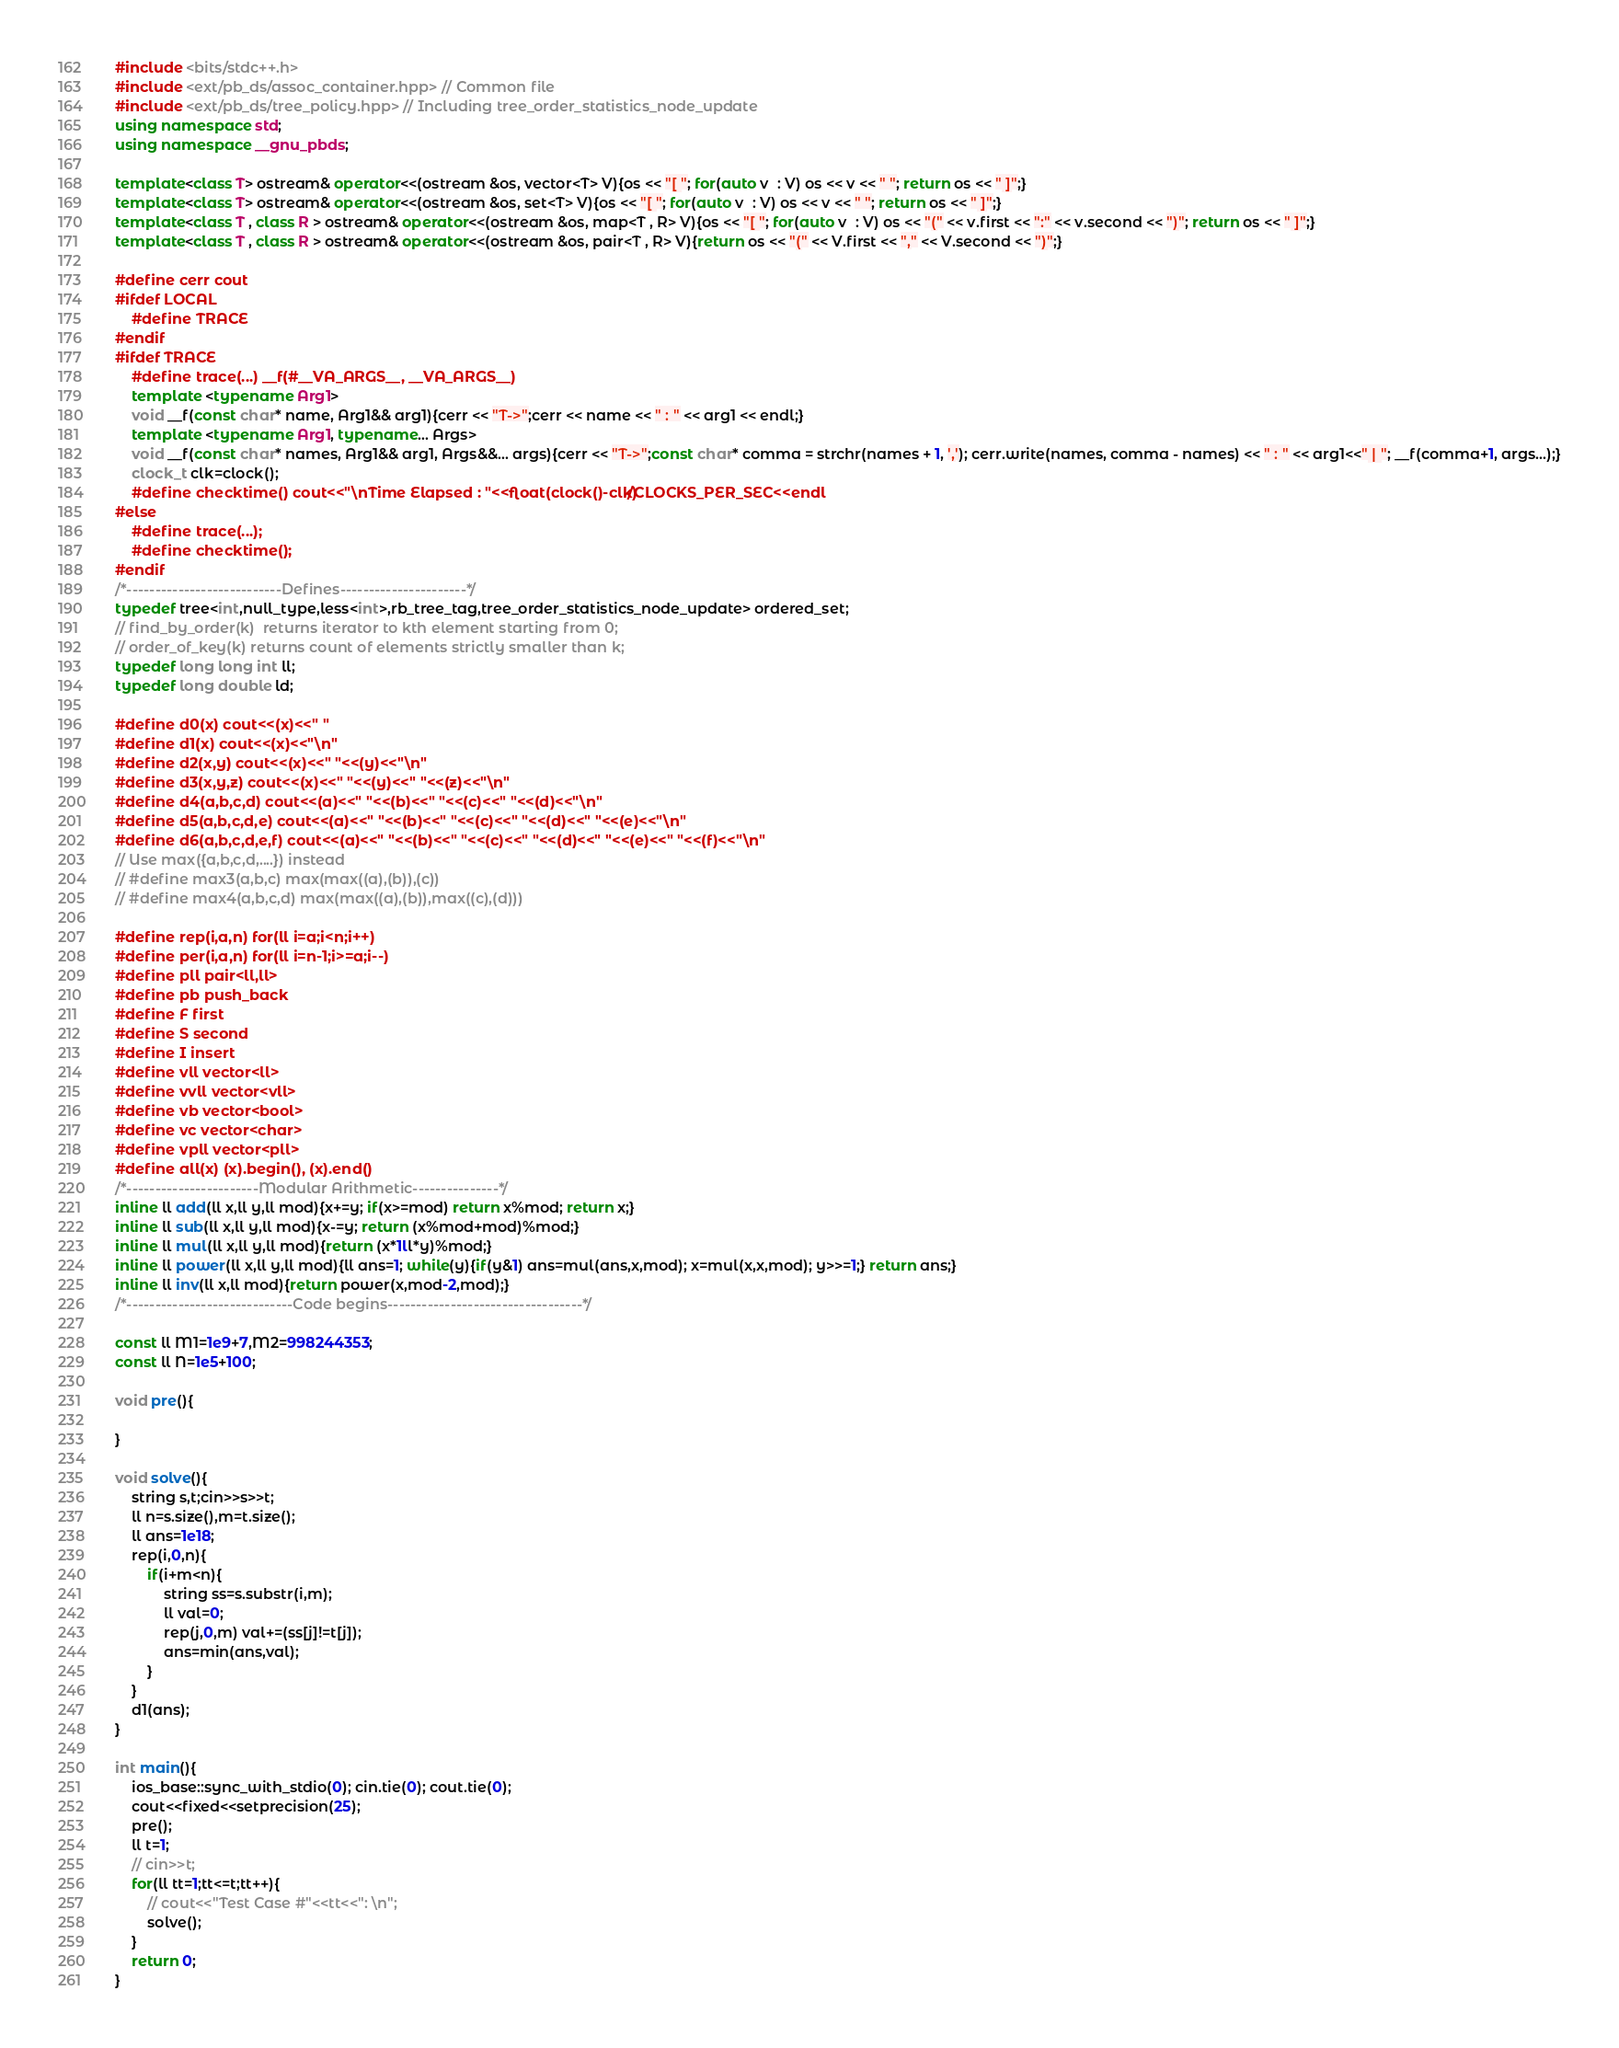Convert code to text. <code><loc_0><loc_0><loc_500><loc_500><_C++_>#include <bits/stdc++.h>
#include <ext/pb_ds/assoc_container.hpp> // Common file
#include <ext/pb_ds/tree_policy.hpp> // Including tree_order_statistics_node_update
using namespace std;
using namespace __gnu_pbds;

template<class T> ostream& operator<<(ostream &os, vector<T> V){os << "[ "; for(auto v  : V) os << v << " "; return os << " ]";}
template<class T> ostream& operator<<(ostream &os, set<T> V){os << "[ "; for(auto v  : V) os << v << " "; return os << " ]";}
template<class T , class R > ostream& operator<<(ostream &os, map<T , R> V){os << "[ "; for(auto v  : V) os << "(" << v.first << ":" << v.second << ")"; return os << " ]";}
template<class T , class R > ostream& operator<<(ostream &os, pair<T , R> V){return os << "(" << V.first << "," << V.second << ")";}

#define cerr cout
#ifdef LOCAL
    #define TRACE
#endif
#ifdef TRACE
    #define trace(...) __f(#__VA_ARGS__, __VA_ARGS__)
    template <typename Arg1>
    void __f(const char* name, Arg1&& arg1){cerr << "T->";cerr << name << " : " << arg1 << endl;}
    template <typename Arg1, typename... Args>
    void __f(const char* names, Arg1&& arg1, Args&&... args){cerr << "T->";const char* comma = strchr(names + 1, ','); cerr.write(names, comma - names) << " : " << arg1<<" | "; __f(comma+1, args...);}
    clock_t clk=clock();
    #define checktime() cout<<"\nTime Elapsed : "<<float(clock()-clk)/CLOCKS_PER_SEC<<endl
#else
    #define trace(...);
    #define checktime();
#endif
/*---------------------------Defines----------------------*/
typedef tree<int,null_type,less<int>,rb_tree_tag,tree_order_statistics_node_update> ordered_set;
// find_by_order(k)  returns iterator to kth element starting from 0;
// order_of_key(k) returns count of elements strictly smaller than k;
typedef long long int ll;
typedef long double ld;

#define d0(x) cout<<(x)<<" "
#define d1(x) cout<<(x)<<"\n"
#define d2(x,y) cout<<(x)<<" "<<(y)<<"\n"
#define d3(x,y,z) cout<<(x)<<" "<<(y)<<" "<<(z)<<"\n"
#define d4(a,b,c,d) cout<<(a)<<" "<<(b)<<" "<<(c)<<" "<<(d)<<"\n"
#define d5(a,b,c,d,e) cout<<(a)<<" "<<(b)<<" "<<(c)<<" "<<(d)<<" "<<(e)<<"\n"
#define d6(a,b,c,d,e,f) cout<<(a)<<" "<<(b)<<" "<<(c)<<" "<<(d)<<" "<<(e)<<" "<<(f)<<"\n"
// Use max({a,b,c,d,....}) instead
// #define max3(a,b,c) max(max((a),(b)),(c))
// #define max4(a,b,c,d) max(max((a),(b)),max((c),(d)))

#define rep(i,a,n) for(ll i=a;i<n;i++)
#define per(i,a,n) for(ll i=n-1;i>=a;i--)
#define pll pair<ll,ll>
#define pb push_back
#define F first
#define S second
#define I insert
#define vll vector<ll>
#define vvll vector<vll>
#define vb vector<bool>
#define vc vector<char>
#define vpll vector<pll>
#define all(x) (x).begin(), (x).end()
/*-----------------------Modular Arithmetic---------------*/
inline ll add(ll x,ll y,ll mod){x+=y; if(x>=mod) return x%mod; return x;}
inline ll sub(ll x,ll y,ll mod){x-=y; return (x%mod+mod)%mod;}
inline ll mul(ll x,ll y,ll mod){return (x*1ll*y)%mod;}
inline ll power(ll x,ll y,ll mod){ll ans=1; while(y){if(y&1) ans=mul(ans,x,mod); x=mul(x,x,mod); y>>=1;} return ans;}
inline ll inv(ll x,ll mod){return power(x,mod-2,mod);}
/*-----------------------------Code begins----------------------------------*/

const ll M1=1e9+7,M2=998244353;
const ll N=1e5+100;

void pre(){
    
}

void solve(){
    string s,t;cin>>s>>t;
    ll n=s.size(),m=t.size();
    ll ans=1e18;
    rep(i,0,n){
        if(i+m<n){
            string ss=s.substr(i,m);
            ll val=0;
            rep(j,0,m) val+=(ss[j]!=t[j]);
            ans=min(ans,val);
        }
    }
    d1(ans);
}

int main(){
    ios_base::sync_with_stdio(0); cin.tie(0); cout.tie(0);
    cout<<fixed<<setprecision(25);
    pre();
    ll t=1;
    // cin>>t;
    for(ll tt=1;tt<=t;tt++){
        // cout<<"Test Case #"<<tt<<": \n";
        solve();
    }
    return 0;
}</code> 